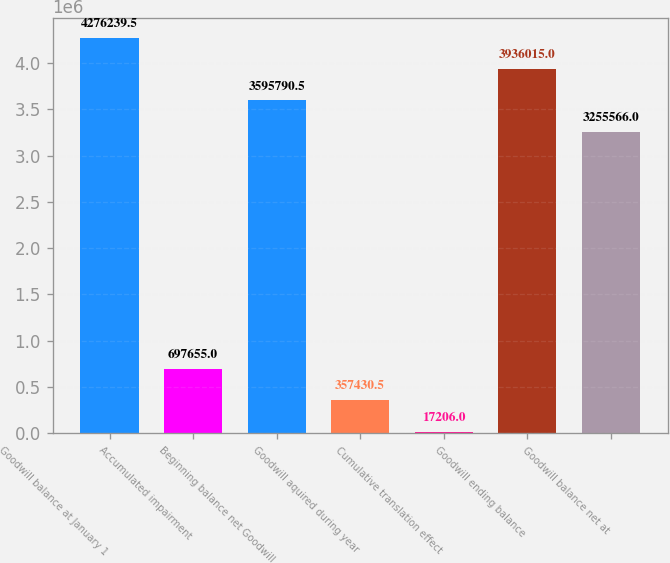Convert chart to OTSL. <chart><loc_0><loc_0><loc_500><loc_500><bar_chart><fcel>Goodwill balance at January 1<fcel>Accumulated impairment<fcel>Beginning balance net Goodwill<fcel>Goodwill aquired during year<fcel>Cumulative translation effect<fcel>Goodwill ending balance<fcel>Goodwill balance net at<nl><fcel>4.27624e+06<fcel>697655<fcel>3.59579e+06<fcel>357430<fcel>17206<fcel>3.93602e+06<fcel>3.25557e+06<nl></chart> 